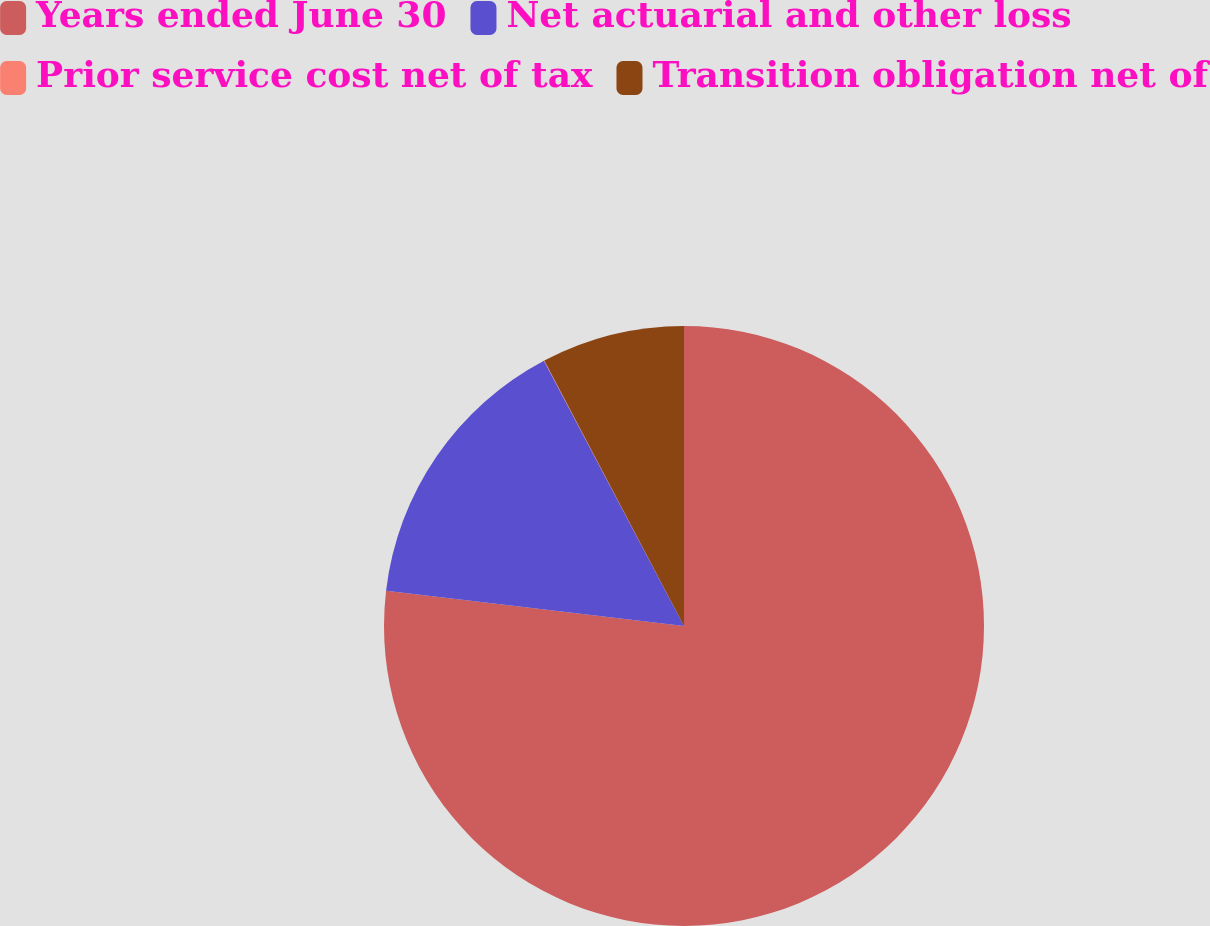<chart> <loc_0><loc_0><loc_500><loc_500><pie_chart><fcel>Years ended June 30<fcel>Net actuarial and other loss<fcel>Prior service cost net of tax<fcel>Transition obligation net of<nl><fcel>76.88%<fcel>15.39%<fcel>0.02%<fcel>7.71%<nl></chart> 